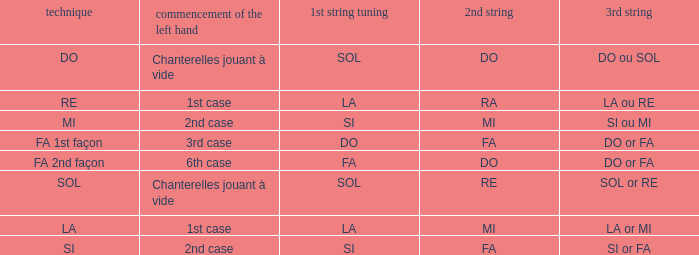For a 1st string of si accord du and a 2nd string of mi, what is the following string? SI ou MI. 